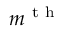<formula> <loc_0><loc_0><loc_500><loc_500>m ^ { t h }</formula> 